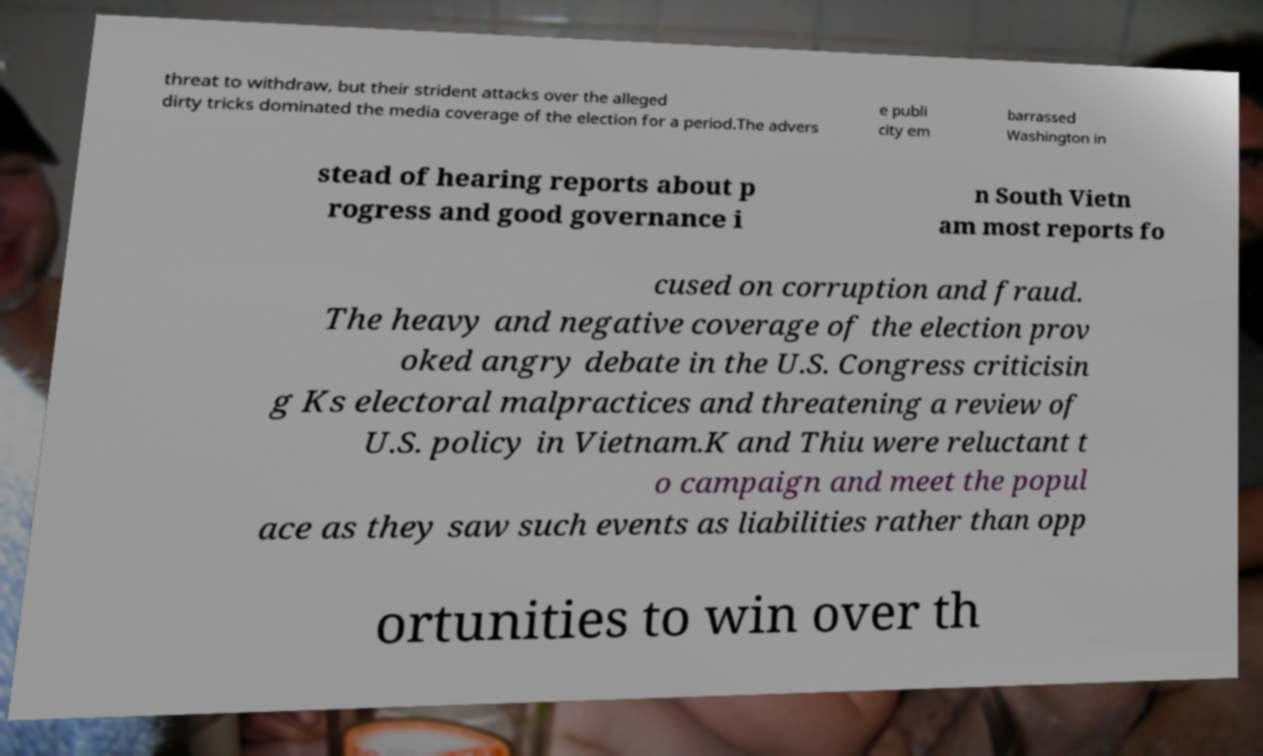I need the written content from this picture converted into text. Can you do that? threat to withdraw, but their strident attacks over the alleged dirty tricks dominated the media coverage of the election for a period.The advers e publi city em barrassed Washington in stead of hearing reports about p rogress and good governance i n South Vietn am most reports fo cused on corruption and fraud. The heavy and negative coverage of the election prov oked angry debate in the U.S. Congress criticisin g Ks electoral malpractices and threatening a review of U.S. policy in Vietnam.K and Thiu were reluctant t o campaign and meet the popul ace as they saw such events as liabilities rather than opp ortunities to win over th 